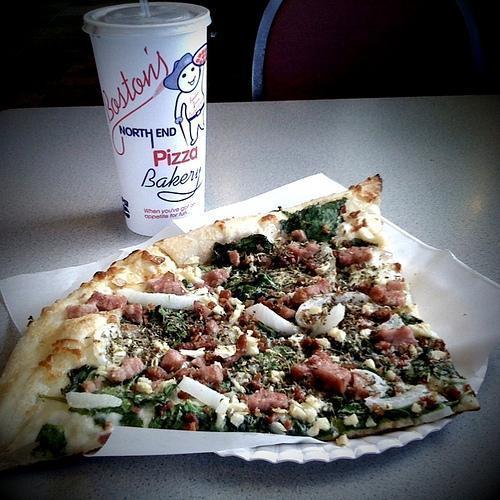How many people are pictured here?
Give a very brief answer. 0. 